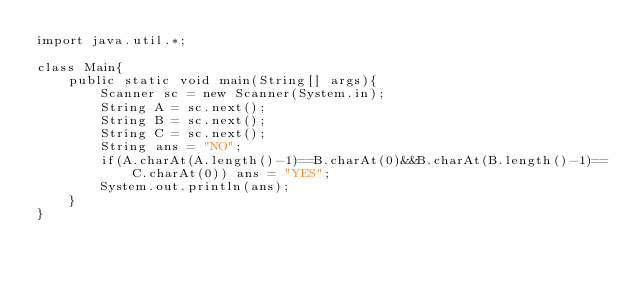Convert code to text. <code><loc_0><loc_0><loc_500><loc_500><_Java_>import java.util.*;

class Main{
    public static void main(String[] args){
        Scanner sc = new Scanner(System.in);
        String A = sc.next();
        String B = sc.next();
        String C = sc.next();
        String ans = "NO";
        if(A.charAt(A.length()-1)==B.charAt(0)&&B.charAt(B.length()-1)==C.charAt(0)) ans = "YES";
        System.out.println(ans);
    }
}
</code> 